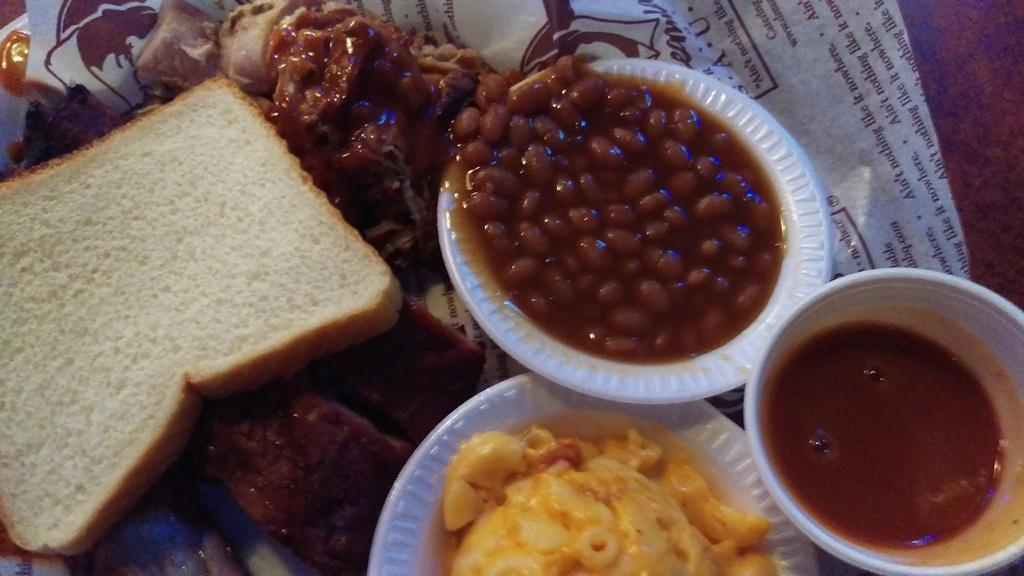What type of food item can be seen in the image? There is bread in the image. What else can be seen in the image besides the bread? There are bowls containing food items and a cup containing sauce in the image. What is the paper used for in the image? The purpose of the paper in the image is not specified, but it is present. What is the table made of in the image? The table in the image is made of wood. What is the color of the table in the image? The table is brown in color. What type of pain can be seen on the faces of the people in the image? There are no people present in the image, so it is not possible to determine if they are experiencing any pain. 